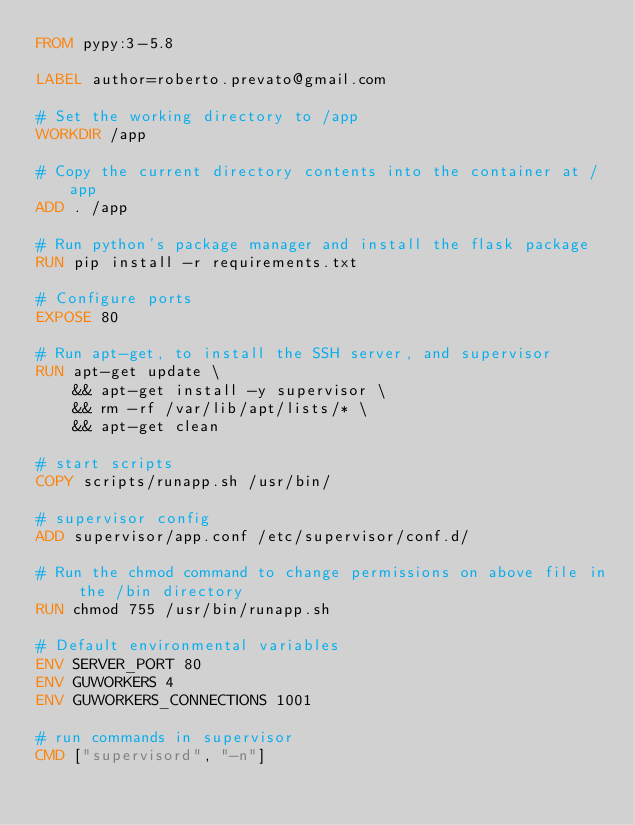<code> <loc_0><loc_0><loc_500><loc_500><_Dockerfile_>FROM pypy:3-5.8

LABEL author=roberto.prevato@gmail.com

# Set the working directory to /app
WORKDIR /app

# Copy the current directory contents into the container at /app
ADD . /app

# Run python's package manager and install the flask package
RUN pip install -r requirements.txt

# Configure ports
EXPOSE 80

# Run apt-get, to install the SSH server, and supervisor
RUN apt-get update \ 
    && apt-get install -y supervisor \
    && rm -rf /var/lib/apt/lists/* \
    && apt-get clean

# start scripts
COPY scripts/runapp.sh /usr/bin/

# supervisor config
ADD supervisor/app.conf /etc/supervisor/conf.d/

# Run the chmod command to change permissions on above file in the /bin directory
RUN chmod 755 /usr/bin/runapp.sh

# Default environmental variables
ENV SERVER_PORT 80
ENV GUWORKERS 4
ENV GUWORKERS_CONNECTIONS 1001

# run commands in supervisor
CMD ["supervisord", "-n"]</code> 